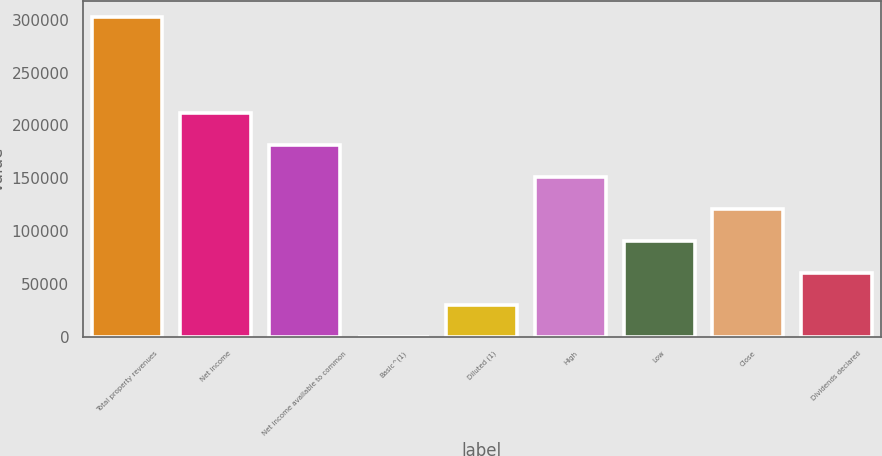<chart> <loc_0><loc_0><loc_500><loc_500><bar_chart><fcel>Total property revenues<fcel>Net income<fcel>Net income available to common<fcel>Basic^(1)<fcel>Diluted (1)<fcel>High<fcel>Low<fcel>Close<fcel>Dividends declared<nl><fcel>302522<fcel>211766<fcel>181513<fcel>0.65<fcel>30252.8<fcel>151261<fcel>90757<fcel>121009<fcel>60504.9<nl></chart> 